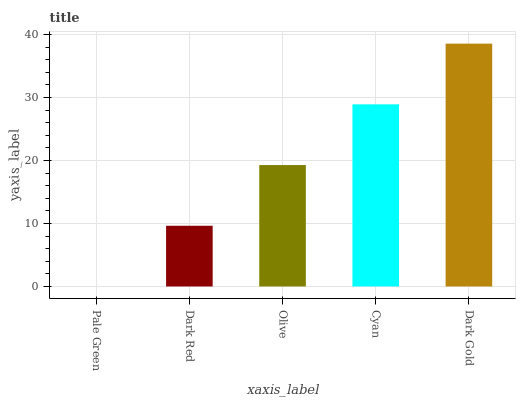Is Pale Green the minimum?
Answer yes or no. Yes. Is Dark Gold the maximum?
Answer yes or no. Yes. Is Dark Red the minimum?
Answer yes or no. No. Is Dark Red the maximum?
Answer yes or no. No. Is Dark Red greater than Pale Green?
Answer yes or no. Yes. Is Pale Green less than Dark Red?
Answer yes or no. Yes. Is Pale Green greater than Dark Red?
Answer yes or no. No. Is Dark Red less than Pale Green?
Answer yes or no. No. Is Olive the high median?
Answer yes or no. Yes. Is Olive the low median?
Answer yes or no. Yes. Is Pale Green the high median?
Answer yes or no. No. Is Cyan the low median?
Answer yes or no. No. 